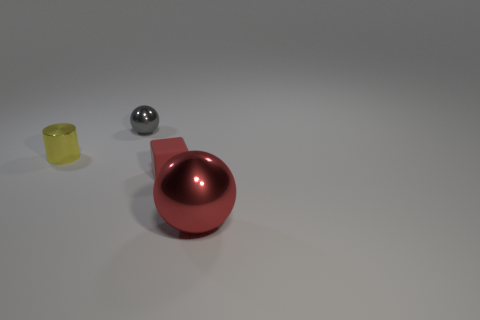What could be the use of the yellow object? The yellow object, resembling a cup or container, could have multiple purposes. It might be used for holding small items, serving as a plant pot, or as a simple drinking vessel. The exact function could vary depending on additional context not provided in the image. 